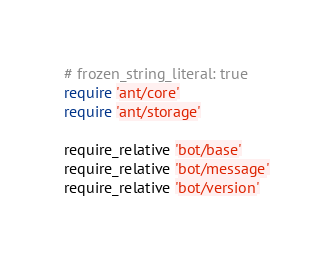Convert code to text. <code><loc_0><loc_0><loc_500><loc_500><_Ruby_># frozen_string_literal: true
require 'ant/core'
require 'ant/storage'

require_relative 'bot/base'
require_relative 'bot/message'
require_relative 'bot/version'
</code> 